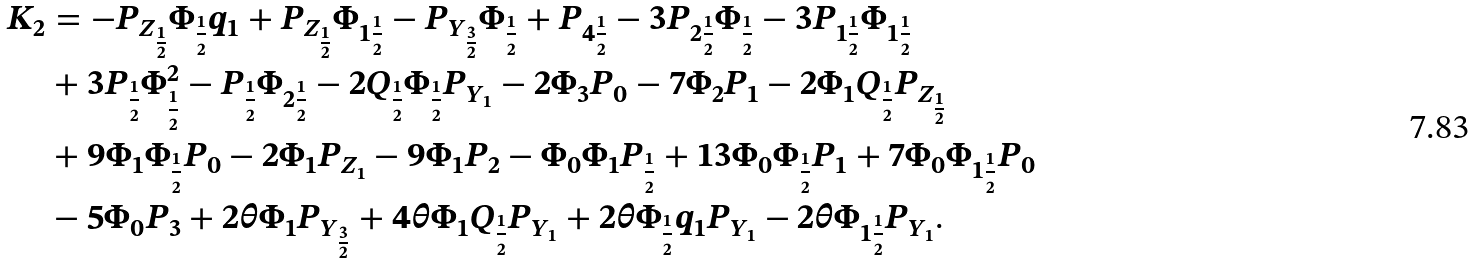<formula> <loc_0><loc_0><loc_500><loc_500>K _ { 2 } & = - P _ { Z _ { \frac { 1 } { 2 } } } \Phi _ { \frac { 1 } { 2 } } q _ { 1 } + P _ { Z _ { \frac { 1 } { 2 } } } \Phi _ { 1 \frac { 1 } { 2 } } - P _ { Y _ { \frac { 3 } { 2 } } } \Phi _ { \frac { 1 } { 2 } } + P _ { 4 \frac { 1 } { 2 } } - 3 P _ { 2 \frac { 1 } { 2 } } \Phi _ { \frac { 1 } { 2 } } - 3 P _ { 1 \frac { 1 } { 2 } } \Phi _ { 1 \frac { 1 } { 2 } } \\ & + 3 P _ { \frac { 1 } { 2 } } \Phi _ { \frac { 1 } { 2 } } ^ { 2 } - P _ { \frac { 1 } { 2 } } \Phi _ { 2 \frac { 1 } { 2 } } - 2 Q _ { \frac { 1 } { 2 } } \Phi _ { \frac { 1 } { 2 } } P _ { Y _ { 1 } } - 2 \Phi _ { 3 } P _ { 0 } - 7 \Phi _ { 2 } P _ { 1 } - 2 \Phi _ { 1 } Q _ { \frac { 1 } { 2 } } P _ { Z _ { \frac { 1 } { 2 } } } \\ & + 9 \Phi _ { 1 } \Phi _ { \frac { 1 } { 2 } } P _ { 0 } - 2 \Phi _ { 1 } P _ { Z _ { 1 } } - 9 \Phi _ { 1 } P _ { 2 } - \Phi _ { 0 } \Phi _ { 1 } P _ { \frac { 1 } { 2 } } + 1 3 \Phi _ { 0 } \Phi _ { \frac { 1 } { 2 } } P _ { 1 } + 7 \Phi _ { 0 } \Phi _ { 1 \frac { 1 } { 2 } } P _ { 0 } \\ & - 5 \Phi _ { 0 } P _ { 3 } + 2 \theta \Phi _ { 1 } P _ { Y _ { \frac { 3 } { 2 } } } + 4 \theta \Phi _ { 1 } Q _ { \frac { 1 } { 2 } } P _ { Y _ { 1 } } + 2 \theta \Phi _ { \frac { 1 } { 2 } } q _ { 1 } P _ { Y _ { 1 } } - 2 \theta \Phi _ { 1 \frac { 1 } { 2 } } P _ { Y _ { 1 } } .</formula> 